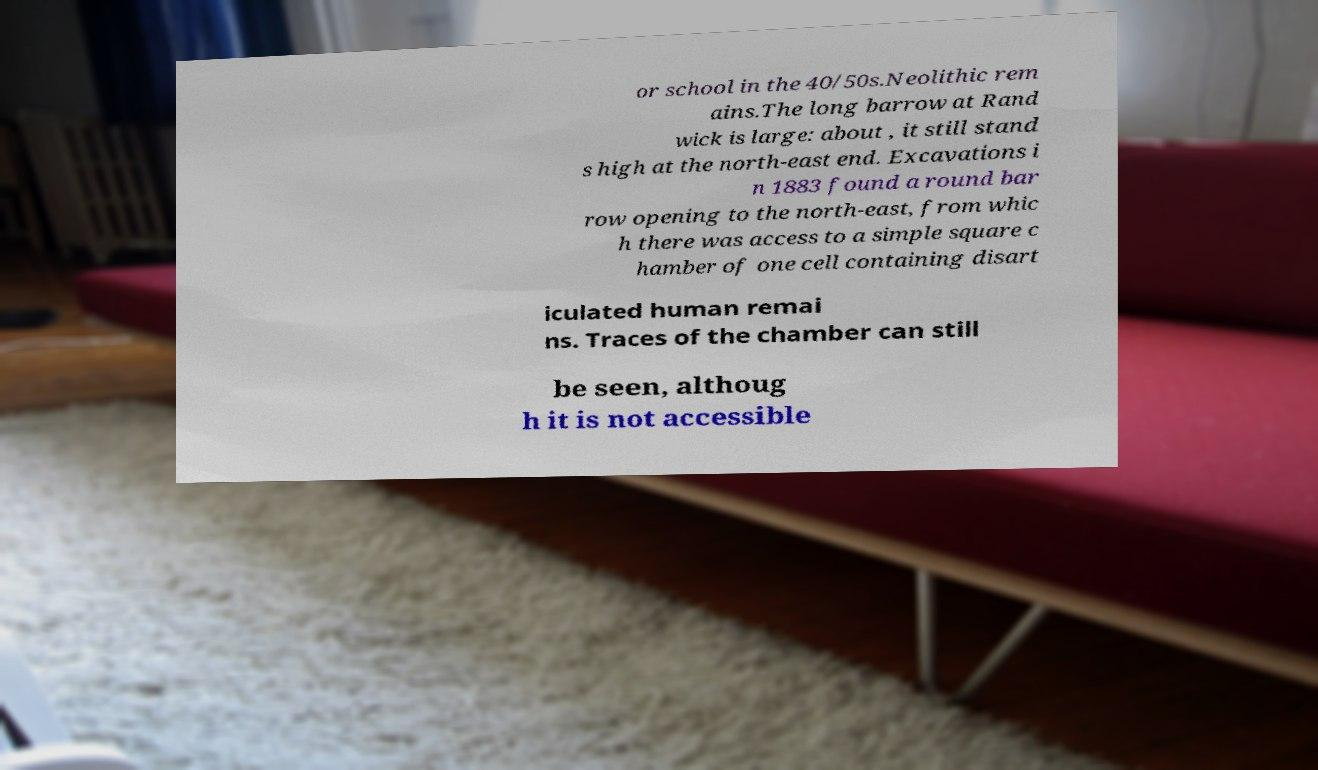Please identify and transcribe the text found in this image. or school in the 40/50s.Neolithic rem ains.The long barrow at Rand wick is large: about , it still stand s high at the north-east end. Excavations i n 1883 found a round bar row opening to the north-east, from whic h there was access to a simple square c hamber of one cell containing disart iculated human remai ns. Traces of the chamber can still be seen, althoug h it is not accessible 